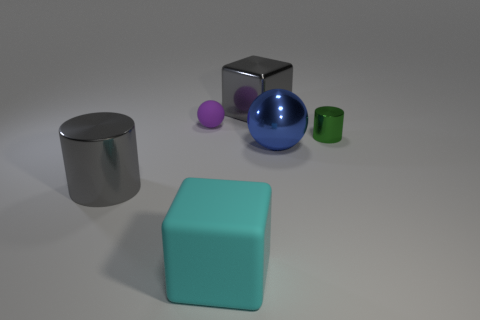There is a block that is the same color as the big shiny cylinder; what size is it?
Your answer should be compact. Large. Is the shape of the rubber object in front of the blue ball the same as the large shiny thing behind the tiny metallic cylinder?
Provide a short and direct response. Yes. Is there a big sphere that has the same material as the large gray cylinder?
Provide a short and direct response. Yes. What number of cyan things are either large rubber things or small things?
Give a very brief answer. 1. There is a object that is in front of the large blue metallic thing and behind the cyan rubber thing; what size is it?
Provide a succinct answer. Large. Are there more purple balls that are behind the gray block than blue metallic spheres?
Provide a short and direct response. No. What number of cylinders are either small green things or tiny cyan things?
Offer a very short reply. 1. There is a shiny thing that is both left of the large blue sphere and in front of the small purple matte thing; what shape is it?
Provide a succinct answer. Cylinder. Are there an equal number of cylinders that are in front of the big gray cube and large rubber blocks that are to the right of the purple object?
Offer a very short reply. No. What number of objects are matte spheres or large gray blocks?
Provide a short and direct response. 2. 